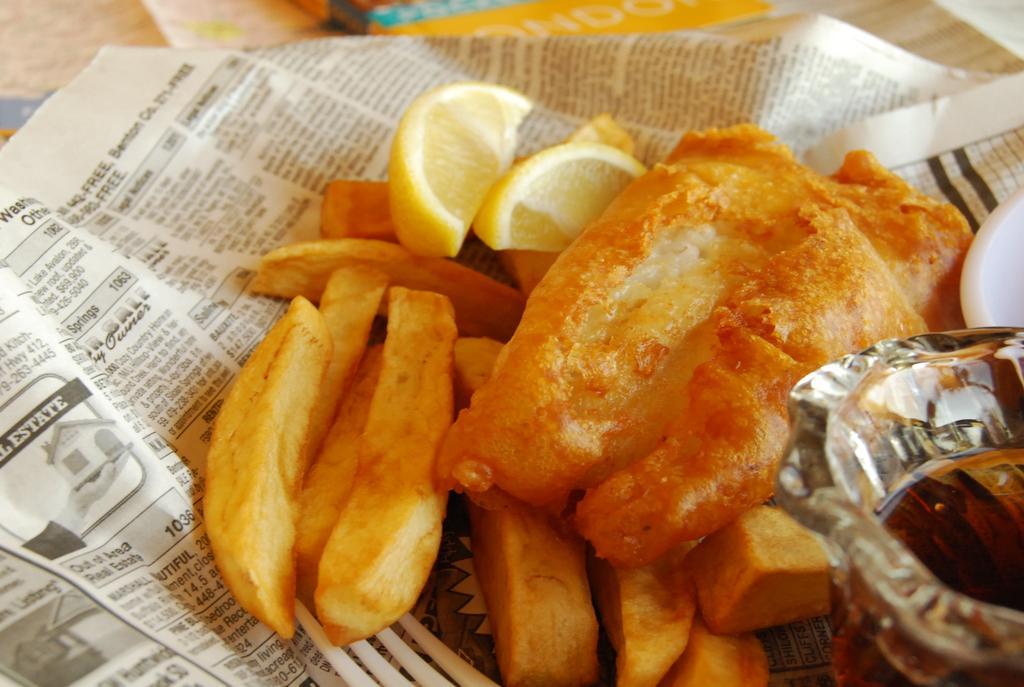<image>
Present a compact description of the photo's key features. A plate of fish and chips sits on a newspaper ad for a house in Lake Avalon 